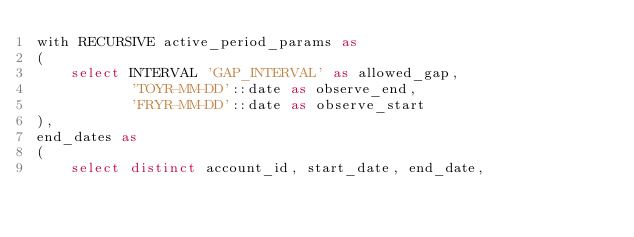Convert code to text. <code><loc_0><loc_0><loc_500><loc_500><_SQL_>with RECURSIVE active_period_params as    
(
	select INTERVAL 'GAP_INTERVAL' as allowed_gap,
	       'TOYR-MM-DD'::date as observe_end,
	       'FRYR-MM-DD'::date as observe_start
),
end_dates as    
(
	select distinct account_id, start_date, end_date, </code> 